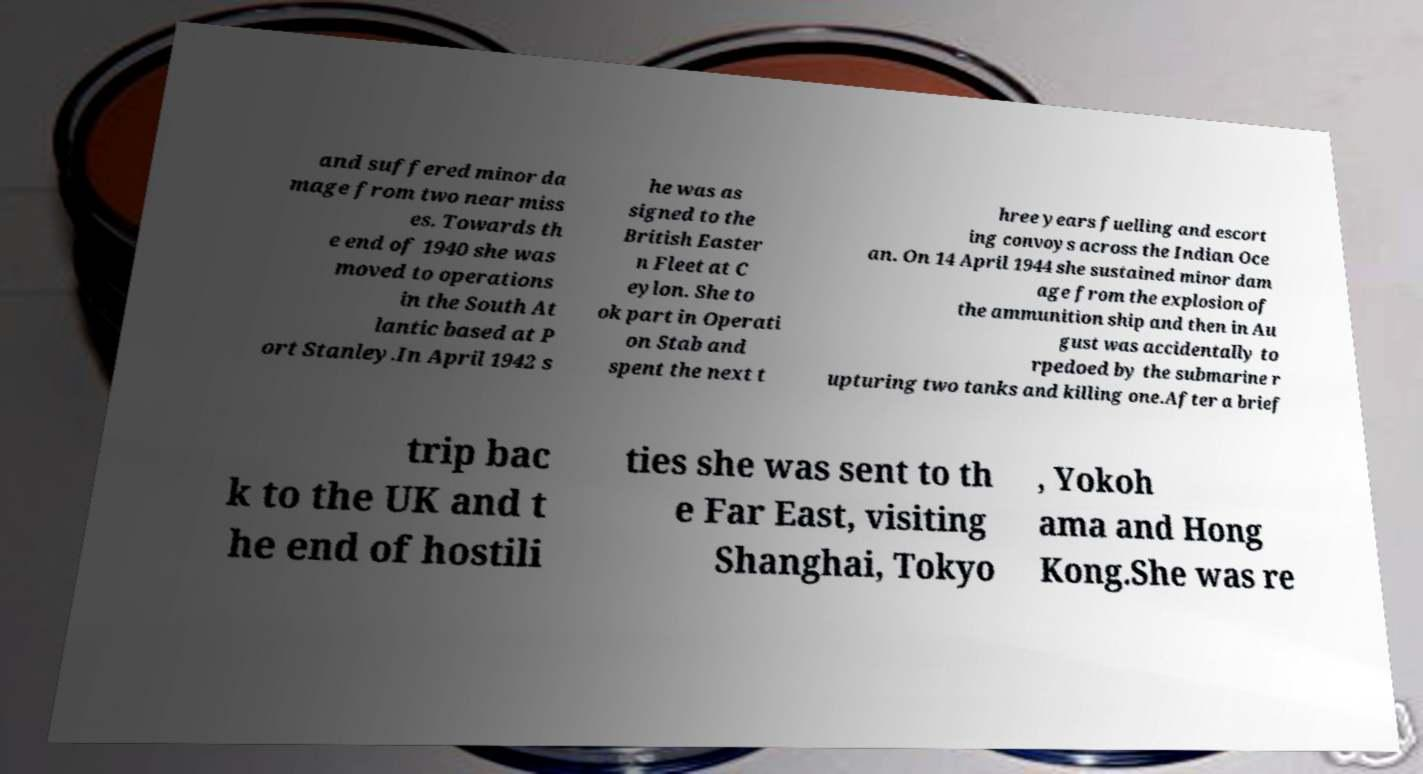I need the written content from this picture converted into text. Can you do that? and suffered minor da mage from two near miss es. Towards th e end of 1940 she was moved to operations in the South At lantic based at P ort Stanley.In April 1942 s he was as signed to the British Easter n Fleet at C eylon. She to ok part in Operati on Stab and spent the next t hree years fuelling and escort ing convoys across the Indian Oce an. On 14 April 1944 she sustained minor dam age from the explosion of the ammunition ship and then in Au gust was accidentally to rpedoed by the submarine r upturing two tanks and killing one.After a brief trip bac k to the UK and t he end of hostili ties she was sent to th e Far East, visiting Shanghai, Tokyo , Yokoh ama and Hong Kong.She was re 